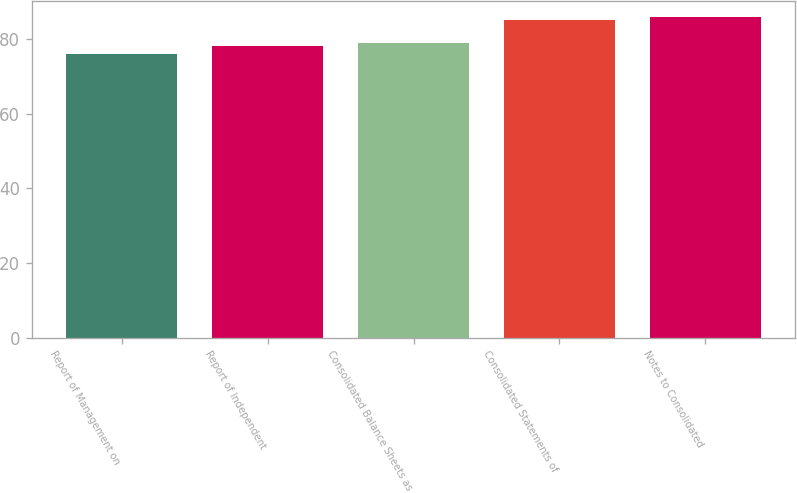Convert chart to OTSL. <chart><loc_0><loc_0><loc_500><loc_500><bar_chart><fcel>Report of Management on<fcel>Report of Independent<fcel>Consolidated Balance Sheets as<fcel>Consolidated Statements of<fcel>Notes to Consolidated<nl><fcel>76<fcel>78<fcel>79<fcel>85<fcel>86<nl></chart> 